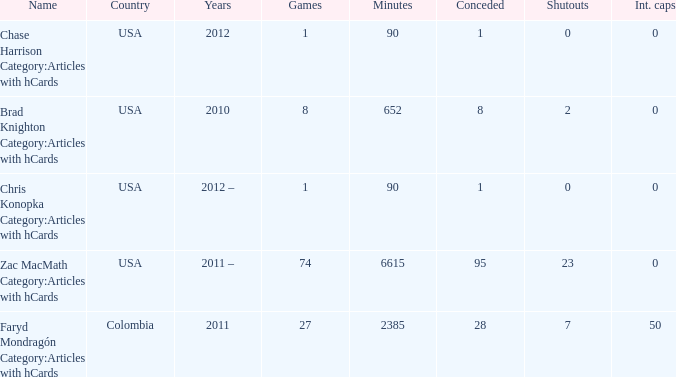In which year does the term "chris konopka category: articles with hcards" refer to? 2012 –. 